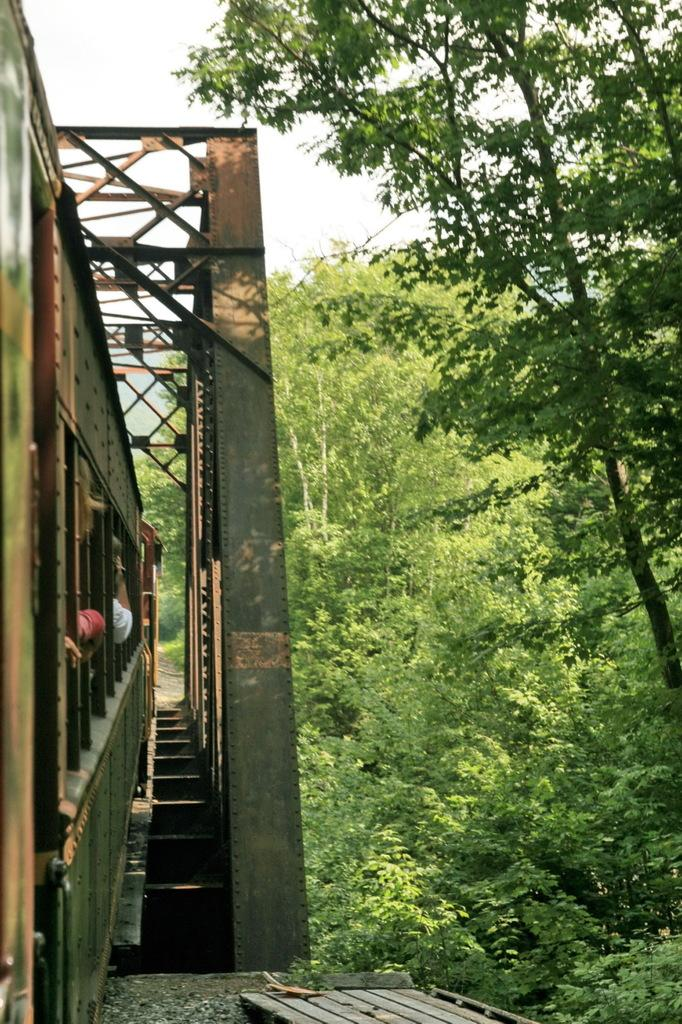What is the main subject of the image? There is a train in the image. Where is the train located? The train is on a track. What can be seen in the background of the image? There are trees and the sky visible in the background. What is the color of the trees? The trees are green. What is the color of the sky? The sky is white in color. Can you see a glove being used by someone on the train in the image? There is no glove visible in the image, nor is anyone using a glove on the train. 